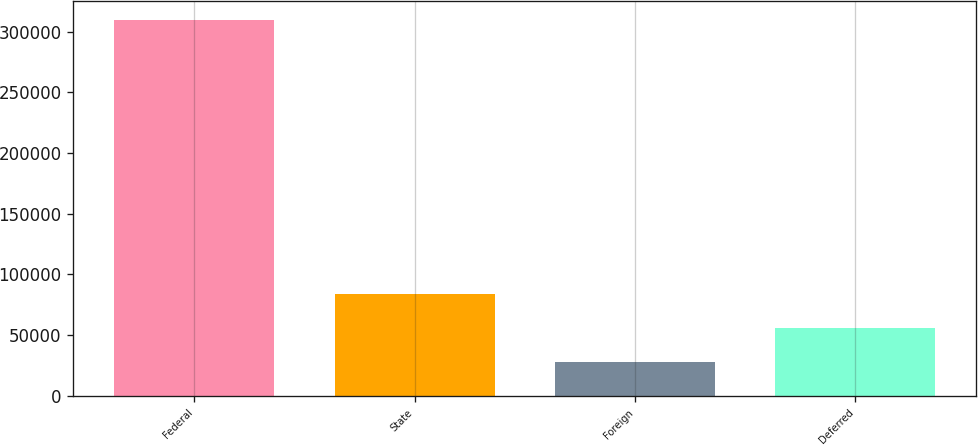Convert chart. <chart><loc_0><loc_0><loc_500><loc_500><bar_chart><fcel>Federal<fcel>State<fcel>Foreign<fcel>Deferred<nl><fcel>309403<fcel>83962.2<fcel>27602<fcel>55782.1<nl></chart> 